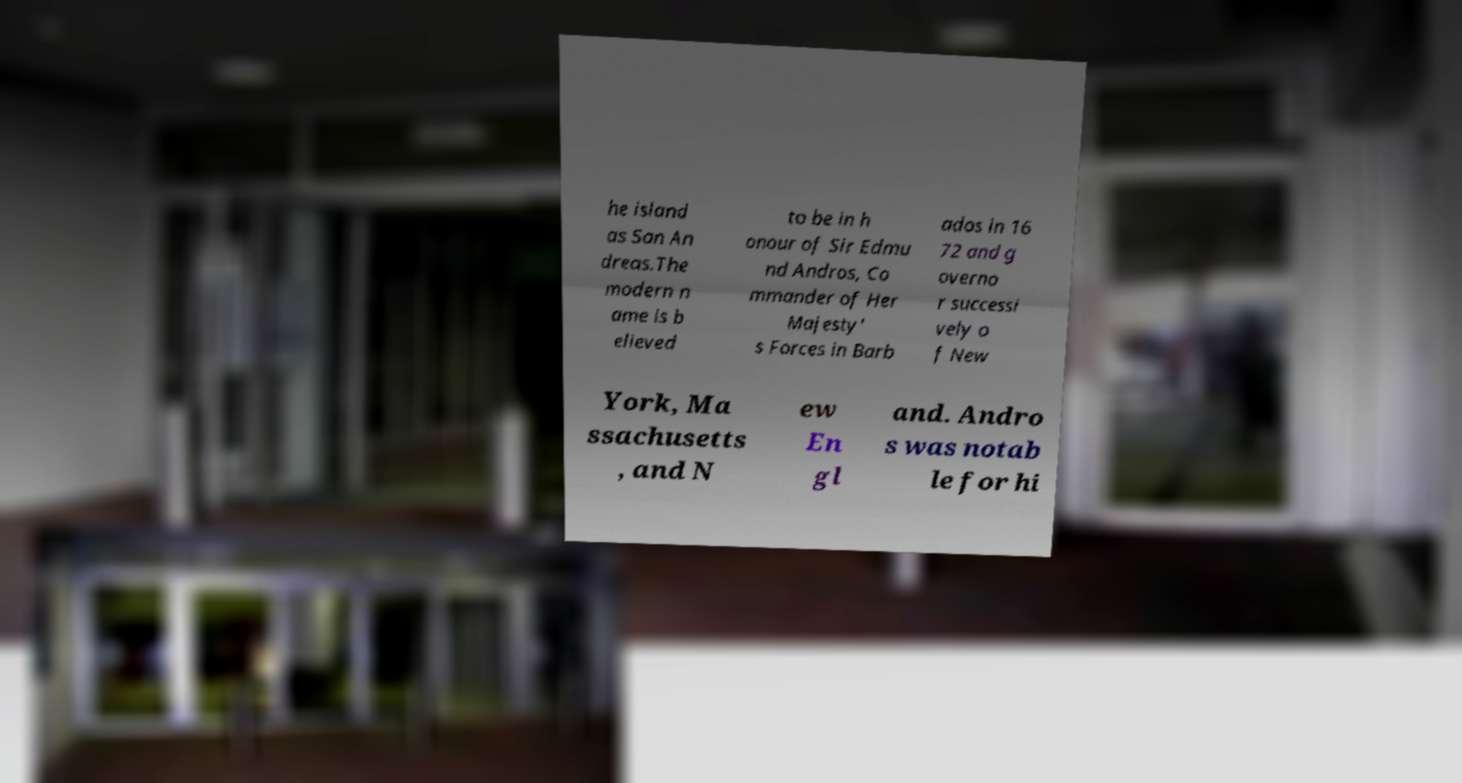What messages or text are displayed in this image? I need them in a readable, typed format. he island as San An dreas.The modern n ame is b elieved to be in h onour of Sir Edmu nd Andros, Co mmander of Her Majesty' s Forces in Barb ados in 16 72 and g overno r successi vely o f New York, Ma ssachusetts , and N ew En gl and. Andro s was notab le for hi 